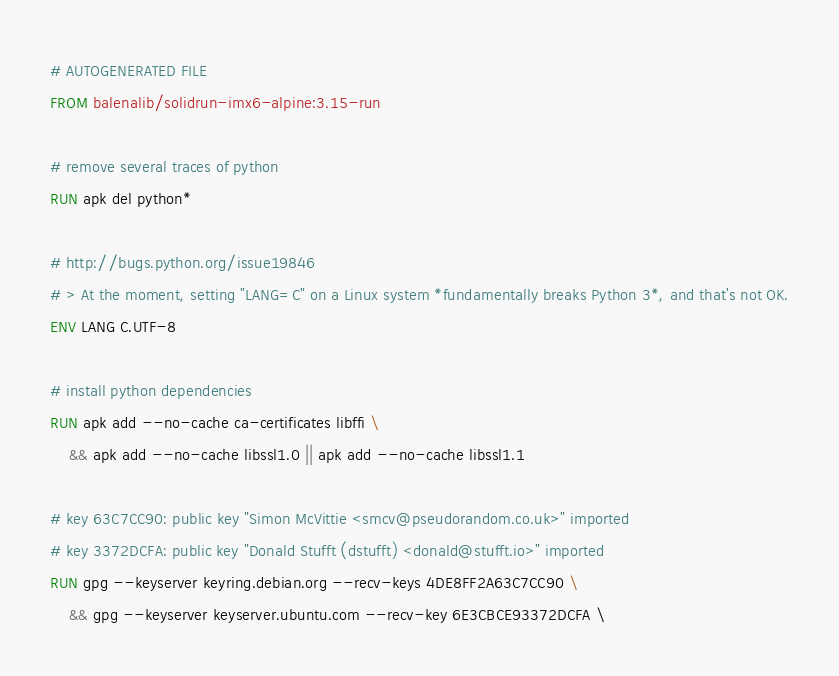<code> <loc_0><loc_0><loc_500><loc_500><_Dockerfile_># AUTOGENERATED FILE
FROM balenalib/solidrun-imx6-alpine:3.15-run

# remove several traces of python
RUN apk del python*

# http://bugs.python.org/issue19846
# > At the moment, setting "LANG=C" on a Linux system *fundamentally breaks Python 3*, and that's not OK.
ENV LANG C.UTF-8

# install python dependencies
RUN apk add --no-cache ca-certificates libffi \
	&& apk add --no-cache libssl1.0 || apk add --no-cache libssl1.1

# key 63C7CC90: public key "Simon McVittie <smcv@pseudorandom.co.uk>" imported
# key 3372DCFA: public key "Donald Stufft (dstufft) <donald@stufft.io>" imported
RUN gpg --keyserver keyring.debian.org --recv-keys 4DE8FF2A63C7CC90 \
	&& gpg --keyserver keyserver.ubuntu.com --recv-key 6E3CBCE93372DCFA \</code> 